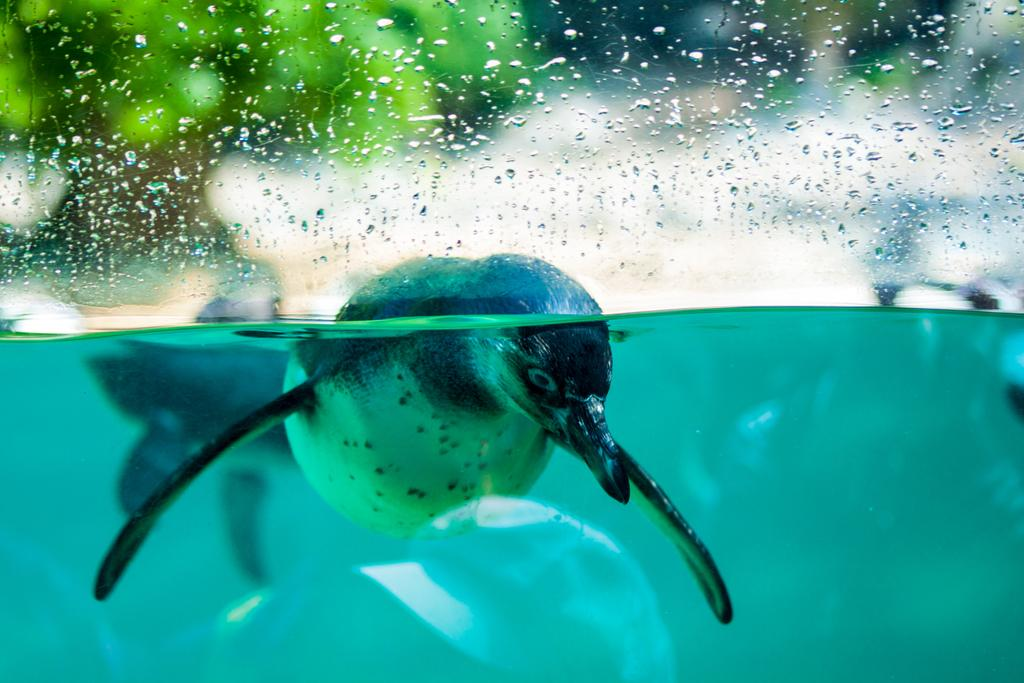What animal is present in the image? There is a Penguin in the image. What is the Penguin's environment in the image? The Penguin is in water. What type of copper material can be seen in the image? There is no copper material present in the image; it features a Penguin in water. What is the selection process for the Penguin in the image? There is no selection process mentioned or depicted in the image, as it simply shows a Penguin in water. 